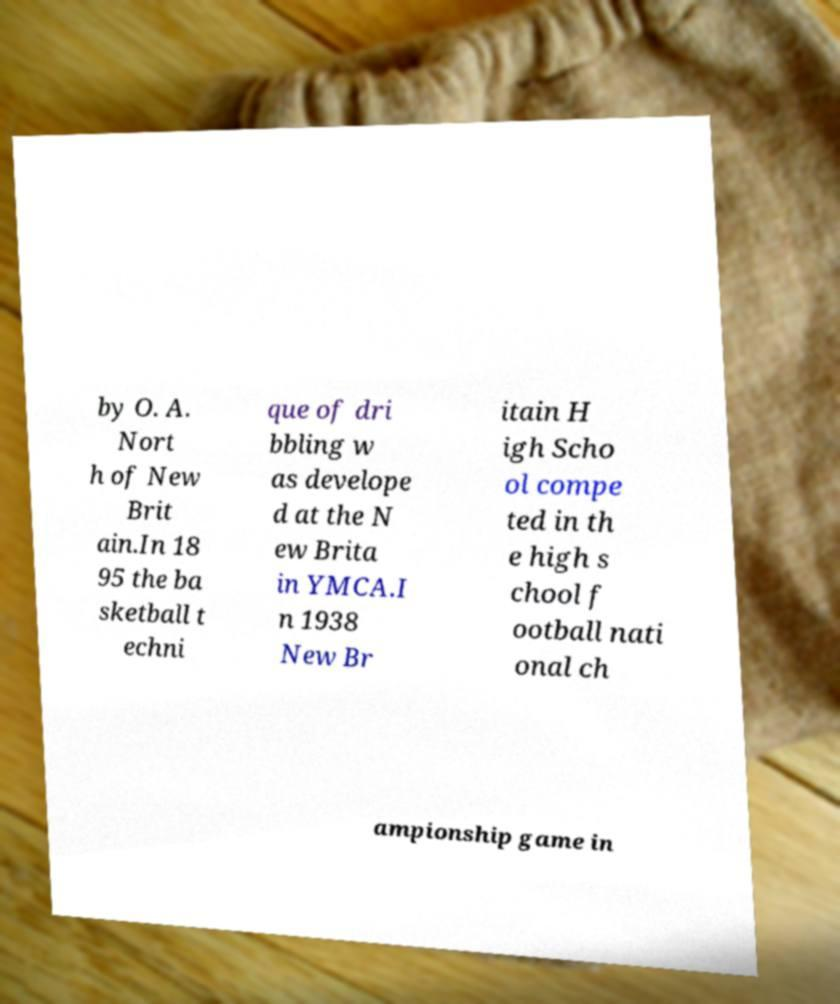For documentation purposes, I need the text within this image transcribed. Could you provide that? by O. A. Nort h of New Brit ain.In 18 95 the ba sketball t echni que of dri bbling w as develope d at the N ew Brita in YMCA.I n 1938 New Br itain H igh Scho ol compe ted in th e high s chool f ootball nati onal ch ampionship game in 